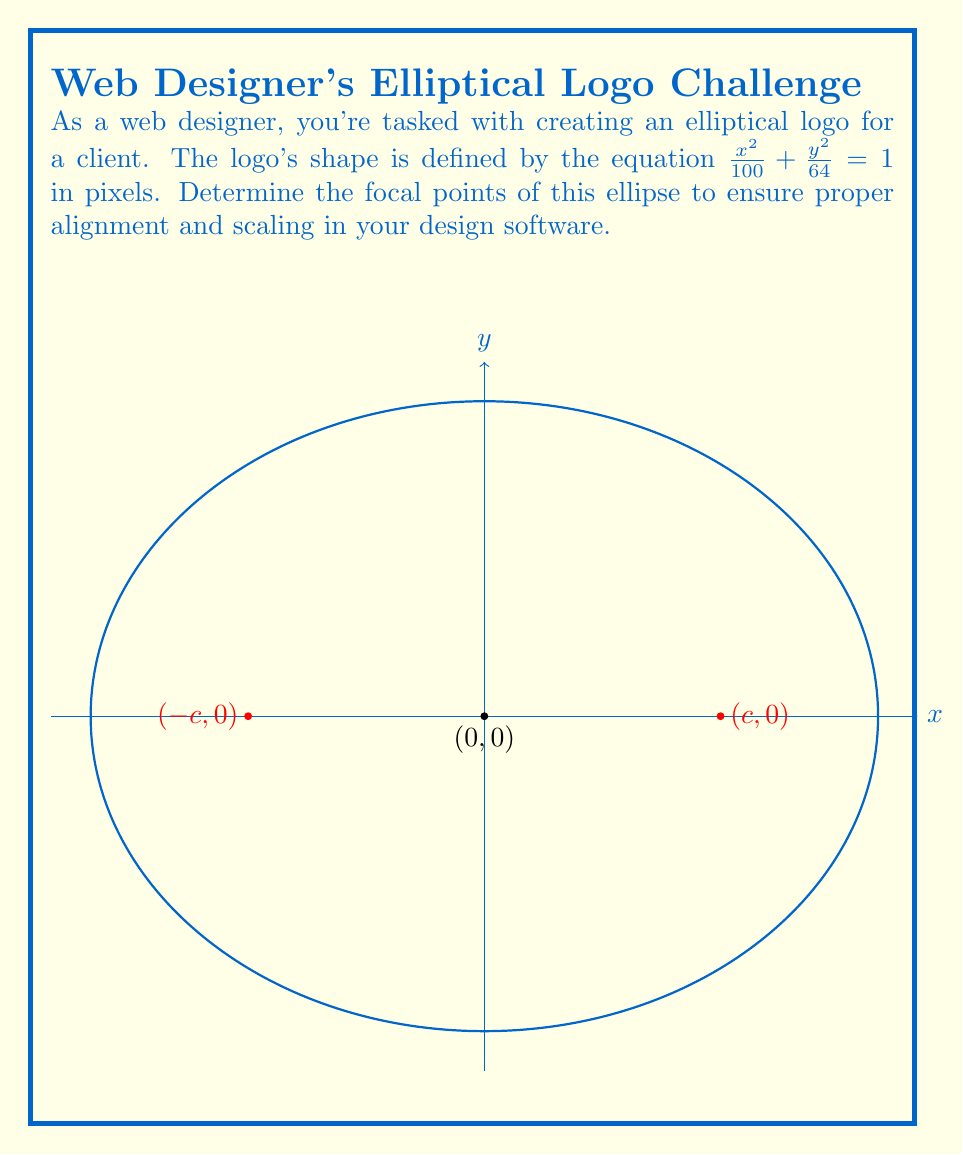What is the answer to this math problem? Let's approach this step-by-step:

1) The general form of an ellipse equation is $\frac{x^2}{a^2} + \frac{y^2}{b^2} = 1$, where $a$ and $b$ are the lengths of the semi-major and semi-minor axes.

2) Comparing our equation $\frac{x^2}{100} + \frac{y^2}{64} = 1$ to the general form, we can deduce:
   $a^2 = 100$ and $b^2 = 64$

3) Therefore:
   $a = \sqrt{100} = 10$ pixels
   $b = \sqrt{64} = 8$ pixels

4) For an ellipse, the focal points are located at $(±c, 0)$, where $c^2 = a^2 - b^2$

5) Let's calculate $c$:
   $c^2 = a^2 - b^2 = 10^2 - 8^2 = 100 - 64 = 36$
   $c = \sqrt{36} = 6$ pixels

6) Therefore, the focal points are located at $(6, 0)$ and $(-6, 0)$ in the pixel coordinate system of your design software.
Answer: $(\pm 6, 0)$ pixels 